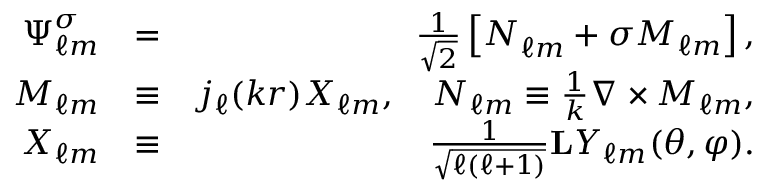<formula> <loc_0><loc_0><loc_500><loc_500>\begin{array} { r l r } { \Psi _ { \ell m } ^ { \sigma } } & { = } & { \frac { 1 } { \sqrt { 2 } } \left [ { N } _ { \ell m } + \sigma { M } _ { \ell m } \right ] , } \\ { { M } _ { \ell m } } & { \equiv } & { j _ { \ell } ( k r ) X _ { \ell m } , \quad N _ { \ell m } \equiv \frac { 1 } { k } \nabla \times { M } _ { \ell m } , } \\ { X _ { \ell m } } & { \equiv } & { \frac { 1 } { \sqrt { \ell ( \ell + 1 ) } } { L } Y _ { \ell m } ( \theta , \varphi ) . } \end{array}</formula> 